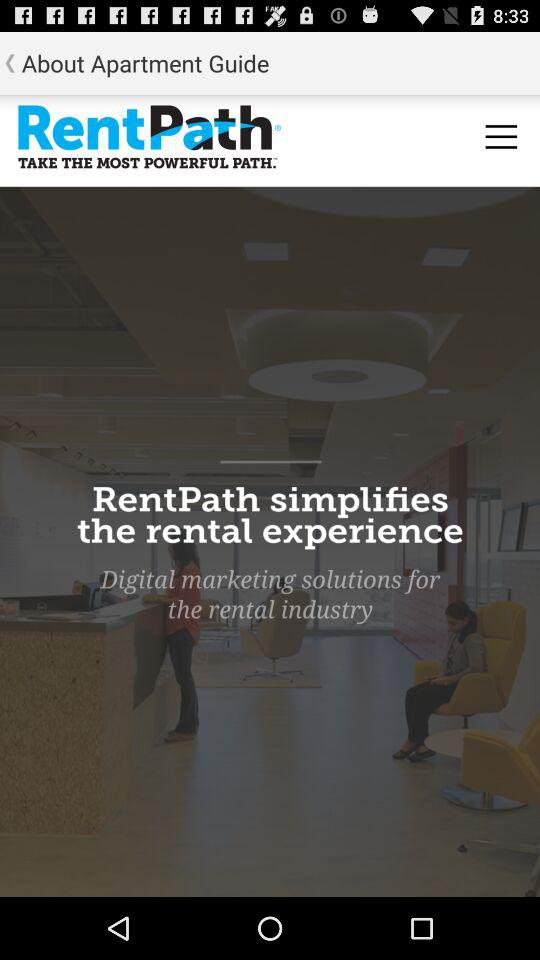What is the app name? The app name is "RentPath". 